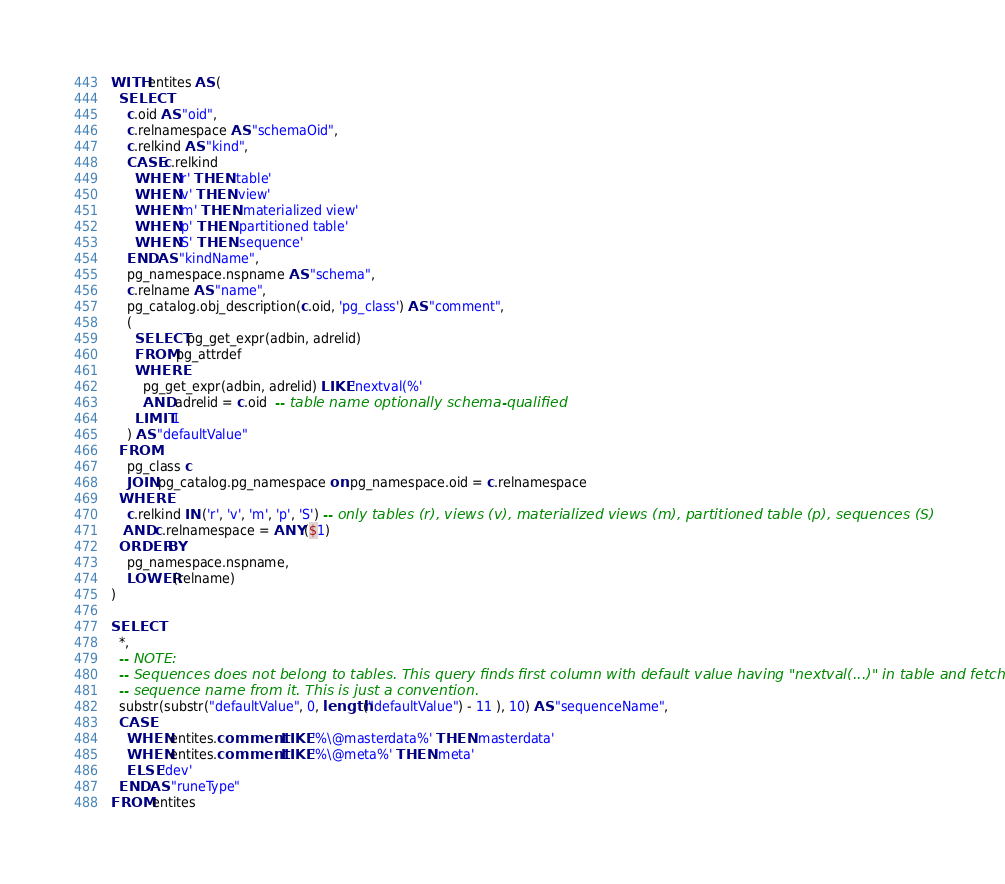Convert code to text. <code><loc_0><loc_0><loc_500><loc_500><_SQL_>WITH entites AS (
  SELECT
    c.oid AS "oid",
    c.relnamespace AS "schemaOid",
    c.relkind AS "kind",
    CASE c.relkind
      WHEN 'r' THEN 'table'
      WHEN 'v' THEN 'view'
      WHEN 'm' THEN 'materialized view'
      WHEN 'p' THEN 'partitioned table'
      WHEN 'S' THEN 'sequence'
    END AS "kindName",
    pg_namespace.nspname AS "schema",
    c.relname AS "name",
    pg_catalog.obj_description(c.oid, 'pg_class') AS "comment",
    (
      SELECT pg_get_expr(adbin, adrelid)
      FROM pg_attrdef
      WHERE
        pg_get_expr(adbin, adrelid) LIKE 'nextval(%'
        AND adrelid = c.oid  -- table name optionally schema-qualified
      LIMIT 1
    ) AS "defaultValue"
  FROM
    pg_class c
    JOIN pg_catalog.pg_namespace on pg_namespace.oid = c.relnamespace
  WHERE
    c.relkind IN ('r', 'v', 'm', 'p', 'S') -- only tables (r), views (v), materialized views (m), partitioned table (p), sequences (S)
   AND c.relnamespace = ANY ($1)
  ORDER BY
    pg_namespace.nspname,
    LOWER(relname)
)

SELECT
  *,
  -- NOTE:
  -- Sequences does not belong to tables. This query finds first column with default value having "nextval(...)" in table and fetches
  -- sequence name from it. This is just a convention.
  substr(substr("defaultValue", 0, length("defaultValue") - 11 ), 10) AS "sequenceName",
  CASE
    WHEN entites.comment LIKE '%\@masterdata%' THEN 'masterdata'
    WHEN entites.comment LIKE '%\@meta%' THEN 'meta'
    ELSE 'dev'
  END AS "runeType"
FROM entites
</code> 